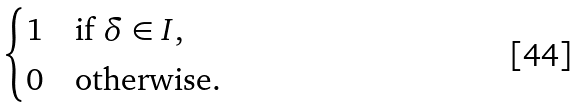<formula> <loc_0><loc_0><loc_500><loc_500>\begin{cases} 1 & \text {if $\delta\in I$,} \\ 0 & \text {otherwise.} \end{cases}</formula> 